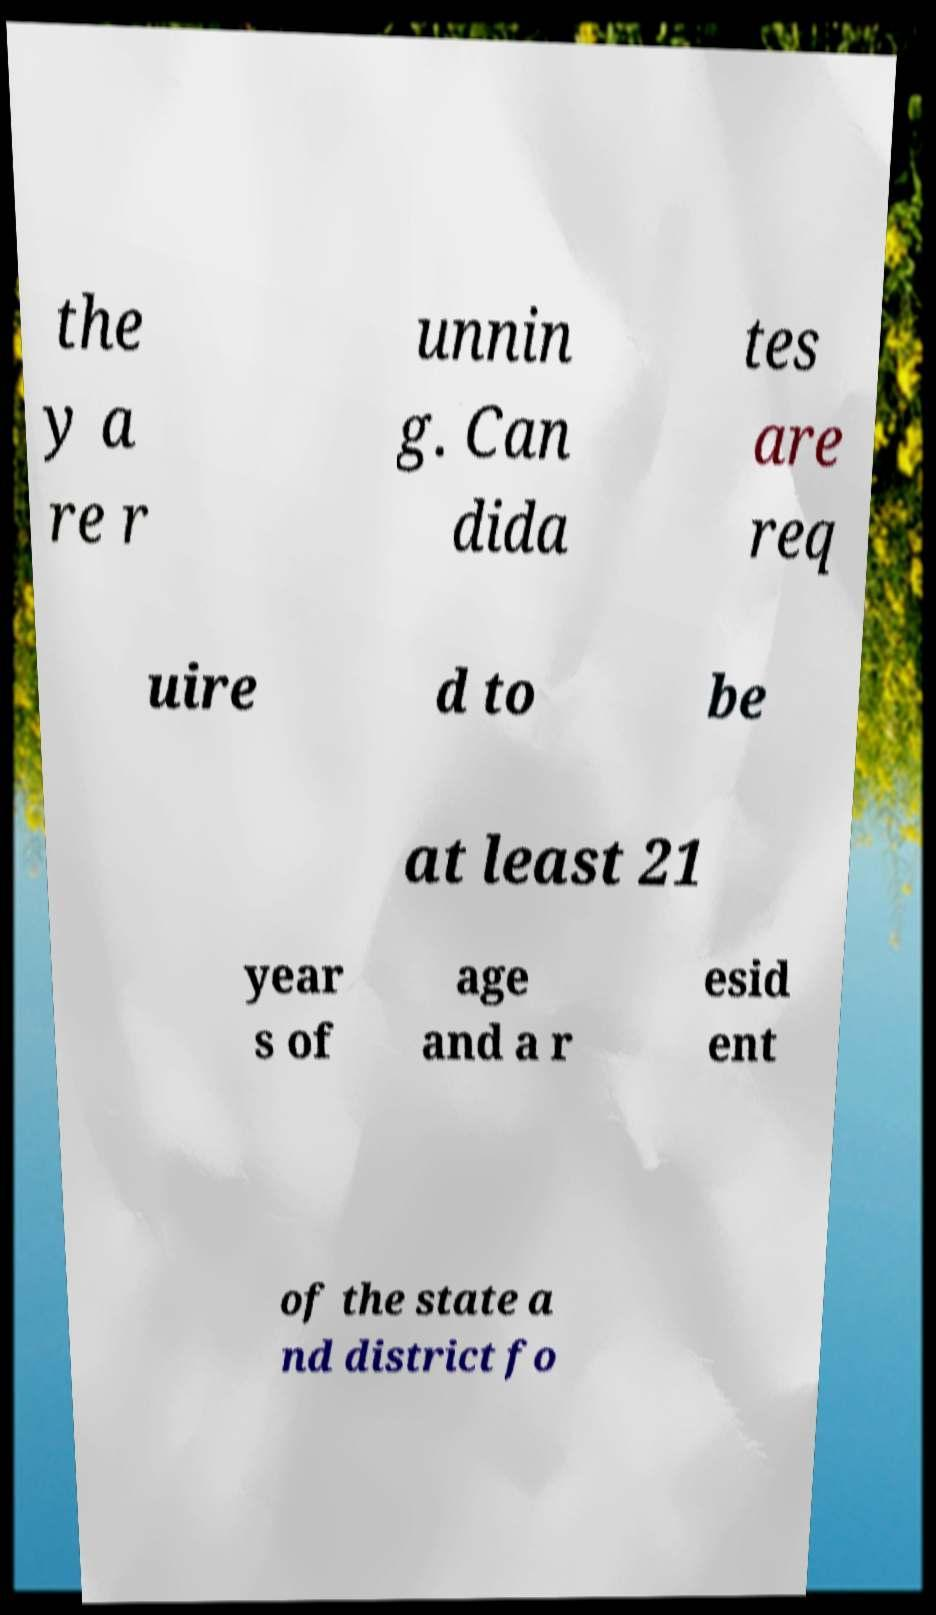Can you accurately transcribe the text from the provided image for me? the y a re r unnin g. Can dida tes are req uire d to be at least 21 year s of age and a r esid ent of the state a nd district fo 